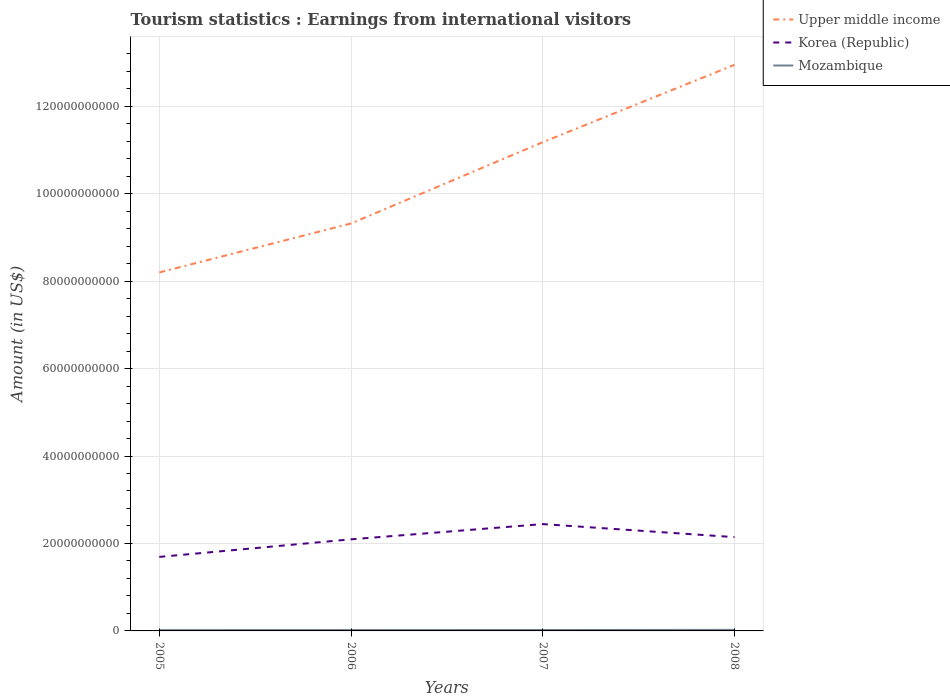Does the line corresponding to Upper middle income intersect with the line corresponding to Korea (Republic)?
Provide a succinct answer. No. Is the number of lines equal to the number of legend labels?
Keep it short and to the point. Yes. Across all years, what is the maximum earnings from international visitors in Mozambique?
Your response must be concise. 1.87e+08. What is the total earnings from international visitors in Korea (Republic) in the graph?
Your answer should be compact. -4.52e+09. What is the difference between the highest and the second highest earnings from international visitors in Upper middle income?
Provide a short and direct response. 4.75e+1. How many lines are there?
Offer a terse response. 3. How many years are there in the graph?
Provide a succinct answer. 4. Does the graph contain any zero values?
Offer a terse response. No. Where does the legend appear in the graph?
Your answer should be compact. Top right. What is the title of the graph?
Your response must be concise. Tourism statistics : Earnings from international visitors. Does "North America" appear as one of the legend labels in the graph?
Your answer should be very brief. No. What is the Amount (in US$) in Upper middle income in 2005?
Your answer should be very brief. 8.20e+1. What is the Amount (in US$) in Korea (Republic) in 2005?
Your response must be concise. 1.69e+1. What is the Amount (in US$) of Mozambique in 2005?
Provide a succinct answer. 1.87e+08. What is the Amount (in US$) in Upper middle income in 2006?
Offer a very short reply. 9.32e+1. What is the Amount (in US$) of Korea (Republic) in 2006?
Offer a terse response. 2.09e+1. What is the Amount (in US$) of Mozambique in 2006?
Provide a short and direct response. 1.96e+08. What is the Amount (in US$) of Upper middle income in 2007?
Your answer should be compact. 1.12e+11. What is the Amount (in US$) of Korea (Republic) in 2007?
Ensure brevity in your answer.  2.44e+1. What is the Amount (in US$) of Mozambique in 2007?
Keep it short and to the point. 2.09e+08. What is the Amount (in US$) in Upper middle income in 2008?
Give a very brief answer. 1.29e+11. What is the Amount (in US$) of Korea (Republic) in 2008?
Your answer should be compact. 2.14e+1. What is the Amount (in US$) of Mozambique in 2008?
Your answer should be very brief. 2.35e+08. Across all years, what is the maximum Amount (in US$) of Upper middle income?
Offer a terse response. 1.29e+11. Across all years, what is the maximum Amount (in US$) of Korea (Republic)?
Provide a short and direct response. 2.44e+1. Across all years, what is the maximum Amount (in US$) of Mozambique?
Make the answer very short. 2.35e+08. Across all years, what is the minimum Amount (in US$) of Upper middle income?
Offer a very short reply. 8.20e+1. Across all years, what is the minimum Amount (in US$) in Korea (Republic)?
Make the answer very short. 1.69e+1. Across all years, what is the minimum Amount (in US$) of Mozambique?
Offer a very short reply. 1.87e+08. What is the total Amount (in US$) in Upper middle income in the graph?
Offer a terse response. 4.16e+11. What is the total Amount (in US$) of Korea (Republic) in the graph?
Your answer should be compact. 8.37e+1. What is the total Amount (in US$) in Mozambique in the graph?
Keep it short and to the point. 8.27e+08. What is the difference between the Amount (in US$) in Upper middle income in 2005 and that in 2006?
Provide a succinct answer. -1.12e+1. What is the difference between the Amount (in US$) in Korea (Republic) in 2005 and that in 2006?
Ensure brevity in your answer.  -4.02e+09. What is the difference between the Amount (in US$) of Mozambique in 2005 and that in 2006?
Give a very brief answer. -9.00e+06. What is the difference between the Amount (in US$) of Upper middle income in 2005 and that in 2007?
Your answer should be very brief. -2.98e+1. What is the difference between the Amount (in US$) in Korea (Republic) in 2005 and that in 2007?
Make the answer very short. -7.51e+09. What is the difference between the Amount (in US$) of Mozambique in 2005 and that in 2007?
Your response must be concise. -2.20e+07. What is the difference between the Amount (in US$) in Upper middle income in 2005 and that in 2008?
Offer a terse response. -4.75e+1. What is the difference between the Amount (in US$) in Korea (Republic) in 2005 and that in 2008?
Provide a succinct answer. -4.52e+09. What is the difference between the Amount (in US$) in Mozambique in 2005 and that in 2008?
Offer a very short reply. -4.80e+07. What is the difference between the Amount (in US$) of Upper middle income in 2006 and that in 2007?
Offer a very short reply. -1.86e+1. What is the difference between the Amount (in US$) of Korea (Republic) in 2006 and that in 2007?
Make the answer very short. -3.48e+09. What is the difference between the Amount (in US$) in Mozambique in 2006 and that in 2007?
Make the answer very short. -1.30e+07. What is the difference between the Amount (in US$) of Upper middle income in 2006 and that in 2008?
Make the answer very short. -3.63e+1. What is the difference between the Amount (in US$) in Korea (Republic) in 2006 and that in 2008?
Ensure brevity in your answer.  -5.00e+08. What is the difference between the Amount (in US$) in Mozambique in 2006 and that in 2008?
Ensure brevity in your answer.  -3.90e+07. What is the difference between the Amount (in US$) in Upper middle income in 2007 and that in 2008?
Your response must be concise. -1.77e+1. What is the difference between the Amount (in US$) in Korea (Republic) in 2007 and that in 2008?
Give a very brief answer. 2.98e+09. What is the difference between the Amount (in US$) in Mozambique in 2007 and that in 2008?
Your answer should be very brief. -2.60e+07. What is the difference between the Amount (in US$) of Upper middle income in 2005 and the Amount (in US$) of Korea (Republic) in 2006?
Offer a very short reply. 6.10e+1. What is the difference between the Amount (in US$) of Upper middle income in 2005 and the Amount (in US$) of Mozambique in 2006?
Make the answer very short. 8.18e+1. What is the difference between the Amount (in US$) of Korea (Republic) in 2005 and the Amount (in US$) of Mozambique in 2006?
Keep it short and to the point. 1.67e+1. What is the difference between the Amount (in US$) of Upper middle income in 2005 and the Amount (in US$) of Korea (Republic) in 2007?
Provide a short and direct response. 5.75e+1. What is the difference between the Amount (in US$) in Upper middle income in 2005 and the Amount (in US$) in Mozambique in 2007?
Ensure brevity in your answer.  8.18e+1. What is the difference between the Amount (in US$) in Korea (Republic) in 2005 and the Amount (in US$) in Mozambique in 2007?
Your answer should be compact. 1.67e+1. What is the difference between the Amount (in US$) of Upper middle income in 2005 and the Amount (in US$) of Korea (Republic) in 2008?
Make the answer very short. 6.05e+1. What is the difference between the Amount (in US$) in Upper middle income in 2005 and the Amount (in US$) in Mozambique in 2008?
Offer a very short reply. 8.17e+1. What is the difference between the Amount (in US$) of Korea (Republic) in 2005 and the Amount (in US$) of Mozambique in 2008?
Offer a very short reply. 1.67e+1. What is the difference between the Amount (in US$) of Upper middle income in 2006 and the Amount (in US$) of Korea (Republic) in 2007?
Your response must be concise. 6.87e+1. What is the difference between the Amount (in US$) of Upper middle income in 2006 and the Amount (in US$) of Mozambique in 2007?
Keep it short and to the point. 9.30e+1. What is the difference between the Amount (in US$) in Korea (Republic) in 2006 and the Amount (in US$) in Mozambique in 2007?
Ensure brevity in your answer.  2.07e+1. What is the difference between the Amount (in US$) in Upper middle income in 2006 and the Amount (in US$) in Korea (Republic) in 2008?
Ensure brevity in your answer.  7.17e+1. What is the difference between the Amount (in US$) in Upper middle income in 2006 and the Amount (in US$) in Mozambique in 2008?
Ensure brevity in your answer.  9.29e+1. What is the difference between the Amount (in US$) of Korea (Republic) in 2006 and the Amount (in US$) of Mozambique in 2008?
Make the answer very short. 2.07e+1. What is the difference between the Amount (in US$) of Upper middle income in 2007 and the Amount (in US$) of Korea (Republic) in 2008?
Provide a succinct answer. 9.03e+1. What is the difference between the Amount (in US$) in Upper middle income in 2007 and the Amount (in US$) in Mozambique in 2008?
Your answer should be very brief. 1.12e+11. What is the difference between the Amount (in US$) in Korea (Republic) in 2007 and the Amount (in US$) in Mozambique in 2008?
Make the answer very short. 2.42e+1. What is the average Amount (in US$) in Upper middle income per year?
Give a very brief answer. 1.04e+11. What is the average Amount (in US$) of Korea (Republic) per year?
Offer a terse response. 2.09e+1. What is the average Amount (in US$) in Mozambique per year?
Give a very brief answer. 2.07e+08. In the year 2005, what is the difference between the Amount (in US$) in Upper middle income and Amount (in US$) in Korea (Republic)?
Provide a short and direct response. 6.51e+1. In the year 2005, what is the difference between the Amount (in US$) of Upper middle income and Amount (in US$) of Mozambique?
Provide a succinct answer. 8.18e+1. In the year 2005, what is the difference between the Amount (in US$) in Korea (Republic) and Amount (in US$) in Mozambique?
Your answer should be very brief. 1.67e+1. In the year 2006, what is the difference between the Amount (in US$) in Upper middle income and Amount (in US$) in Korea (Republic)?
Your answer should be compact. 7.22e+1. In the year 2006, what is the difference between the Amount (in US$) of Upper middle income and Amount (in US$) of Mozambique?
Keep it short and to the point. 9.30e+1. In the year 2006, what is the difference between the Amount (in US$) in Korea (Republic) and Amount (in US$) in Mozambique?
Provide a succinct answer. 2.08e+1. In the year 2007, what is the difference between the Amount (in US$) of Upper middle income and Amount (in US$) of Korea (Republic)?
Offer a very short reply. 8.73e+1. In the year 2007, what is the difference between the Amount (in US$) in Upper middle income and Amount (in US$) in Mozambique?
Offer a very short reply. 1.12e+11. In the year 2007, what is the difference between the Amount (in US$) in Korea (Republic) and Amount (in US$) in Mozambique?
Provide a succinct answer. 2.42e+1. In the year 2008, what is the difference between the Amount (in US$) of Upper middle income and Amount (in US$) of Korea (Republic)?
Your answer should be very brief. 1.08e+11. In the year 2008, what is the difference between the Amount (in US$) of Upper middle income and Amount (in US$) of Mozambique?
Your answer should be compact. 1.29e+11. In the year 2008, what is the difference between the Amount (in US$) in Korea (Republic) and Amount (in US$) in Mozambique?
Keep it short and to the point. 2.12e+1. What is the ratio of the Amount (in US$) of Upper middle income in 2005 to that in 2006?
Offer a very short reply. 0.88. What is the ratio of the Amount (in US$) of Korea (Republic) in 2005 to that in 2006?
Offer a very short reply. 0.81. What is the ratio of the Amount (in US$) in Mozambique in 2005 to that in 2006?
Your answer should be compact. 0.95. What is the ratio of the Amount (in US$) of Upper middle income in 2005 to that in 2007?
Keep it short and to the point. 0.73. What is the ratio of the Amount (in US$) in Korea (Republic) in 2005 to that in 2007?
Your response must be concise. 0.69. What is the ratio of the Amount (in US$) of Mozambique in 2005 to that in 2007?
Offer a very short reply. 0.89. What is the ratio of the Amount (in US$) in Upper middle income in 2005 to that in 2008?
Provide a succinct answer. 0.63. What is the ratio of the Amount (in US$) in Korea (Republic) in 2005 to that in 2008?
Make the answer very short. 0.79. What is the ratio of the Amount (in US$) in Mozambique in 2005 to that in 2008?
Offer a terse response. 0.8. What is the ratio of the Amount (in US$) of Upper middle income in 2006 to that in 2007?
Give a very brief answer. 0.83. What is the ratio of the Amount (in US$) in Korea (Republic) in 2006 to that in 2007?
Make the answer very short. 0.86. What is the ratio of the Amount (in US$) of Mozambique in 2006 to that in 2007?
Your response must be concise. 0.94. What is the ratio of the Amount (in US$) in Upper middle income in 2006 to that in 2008?
Give a very brief answer. 0.72. What is the ratio of the Amount (in US$) of Korea (Republic) in 2006 to that in 2008?
Offer a terse response. 0.98. What is the ratio of the Amount (in US$) in Mozambique in 2006 to that in 2008?
Offer a terse response. 0.83. What is the ratio of the Amount (in US$) of Upper middle income in 2007 to that in 2008?
Provide a short and direct response. 0.86. What is the ratio of the Amount (in US$) in Korea (Republic) in 2007 to that in 2008?
Make the answer very short. 1.14. What is the ratio of the Amount (in US$) of Mozambique in 2007 to that in 2008?
Your answer should be compact. 0.89. What is the difference between the highest and the second highest Amount (in US$) of Upper middle income?
Keep it short and to the point. 1.77e+1. What is the difference between the highest and the second highest Amount (in US$) in Korea (Republic)?
Keep it short and to the point. 2.98e+09. What is the difference between the highest and the second highest Amount (in US$) in Mozambique?
Offer a terse response. 2.60e+07. What is the difference between the highest and the lowest Amount (in US$) of Upper middle income?
Offer a terse response. 4.75e+1. What is the difference between the highest and the lowest Amount (in US$) in Korea (Republic)?
Provide a short and direct response. 7.51e+09. What is the difference between the highest and the lowest Amount (in US$) of Mozambique?
Provide a short and direct response. 4.80e+07. 